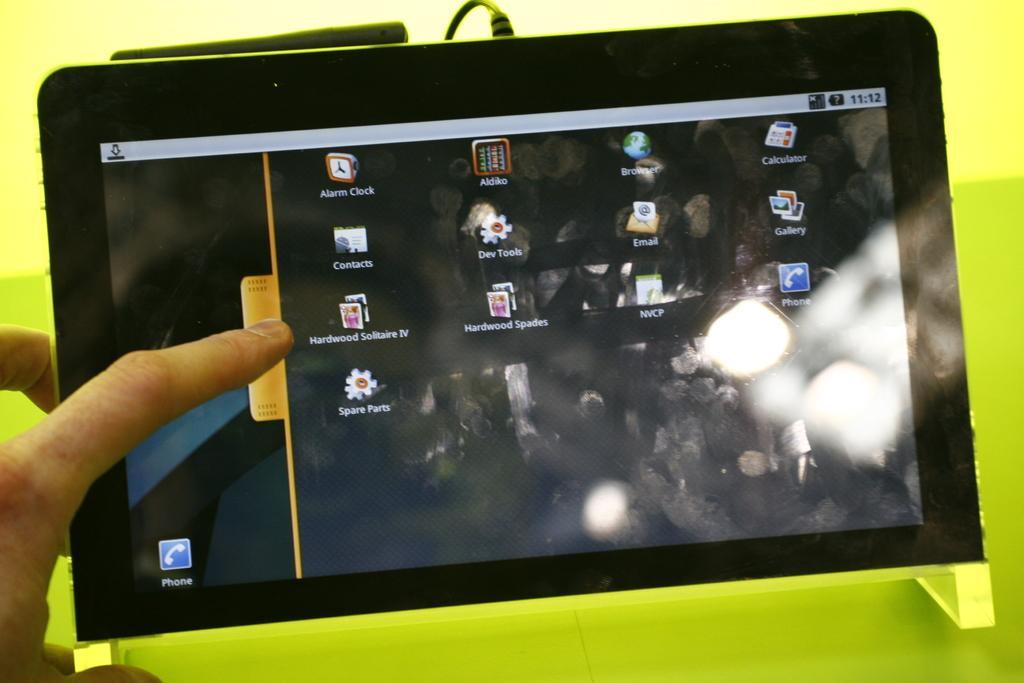Please provide a concise description of this image. In the image we can see a gadget, parrot green color surface, cable wire and human fingers. 